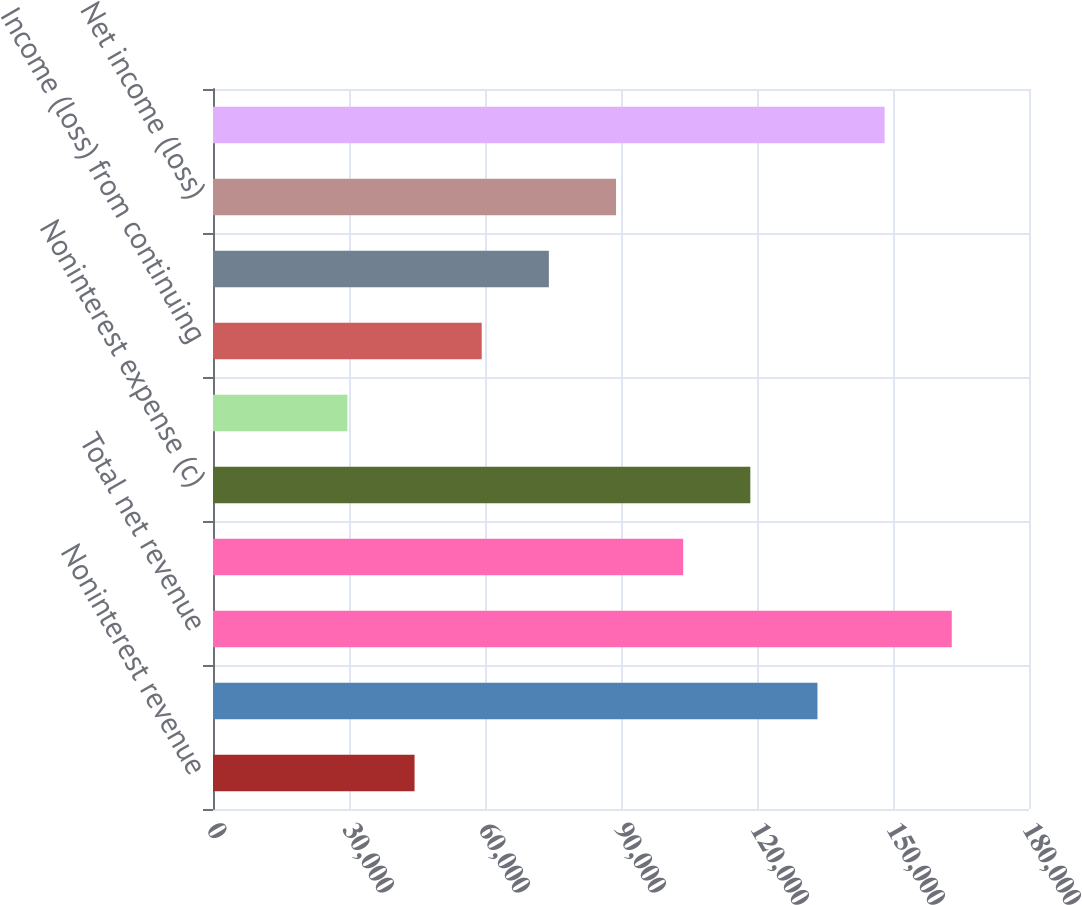<chart> <loc_0><loc_0><loc_500><loc_500><bar_chart><fcel>Noninterest revenue<fcel>Net interest income<fcel>Total net revenue<fcel>Provision for credit losses<fcel>Noninterest expense (c)<fcel>Income tax expense (benefit)<fcel>Income (loss) from continuing<fcel>Income (loss) before<fcel>Net income (loss)<fcel>Average common equity<nl><fcel>44462<fcel>133340<fcel>162966<fcel>103714<fcel>118527<fcel>29649<fcel>59275<fcel>74088<fcel>88901<fcel>148153<nl></chart> 